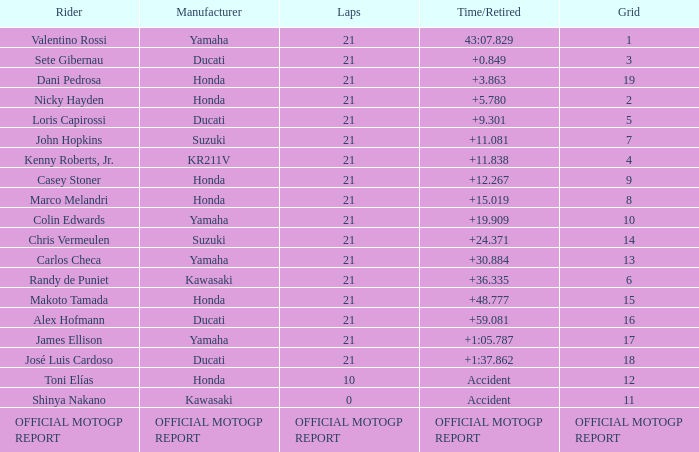WWhich rder had a vehicle manufactured by kr211v? Kenny Roberts, Jr. Write the full table. {'header': ['Rider', 'Manufacturer', 'Laps', 'Time/Retired', 'Grid'], 'rows': [['Valentino Rossi', 'Yamaha', '21', '43:07.829', '1'], ['Sete Gibernau', 'Ducati', '21', '+0.849', '3'], ['Dani Pedrosa', 'Honda', '21', '+3.863', '19'], ['Nicky Hayden', 'Honda', '21', '+5.780', '2'], ['Loris Capirossi', 'Ducati', '21', '+9.301', '5'], ['John Hopkins', 'Suzuki', '21', '+11.081', '7'], ['Kenny Roberts, Jr.', 'KR211V', '21', '+11.838', '4'], ['Casey Stoner', 'Honda', '21', '+12.267', '9'], ['Marco Melandri', 'Honda', '21', '+15.019', '8'], ['Colin Edwards', 'Yamaha', '21', '+19.909', '10'], ['Chris Vermeulen', 'Suzuki', '21', '+24.371', '14'], ['Carlos Checa', 'Yamaha', '21', '+30.884', '13'], ['Randy de Puniet', 'Kawasaki', '21', '+36.335', '6'], ['Makoto Tamada', 'Honda', '21', '+48.777', '15'], ['Alex Hofmann', 'Ducati', '21', '+59.081', '16'], ['James Ellison', 'Yamaha', '21', '+1:05.787', '17'], ['José Luis Cardoso', 'Ducati', '21', '+1:37.862', '18'], ['Toni Elías', 'Honda', '10', 'Accident', '12'], ['Shinya Nakano', 'Kawasaki', '0', 'Accident', '11'], ['OFFICIAL MOTOGP REPORT', 'OFFICIAL MOTOGP REPORT', 'OFFICIAL MOTOGP REPORT', 'OFFICIAL MOTOGP REPORT', 'OFFICIAL MOTOGP REPORT']]} 